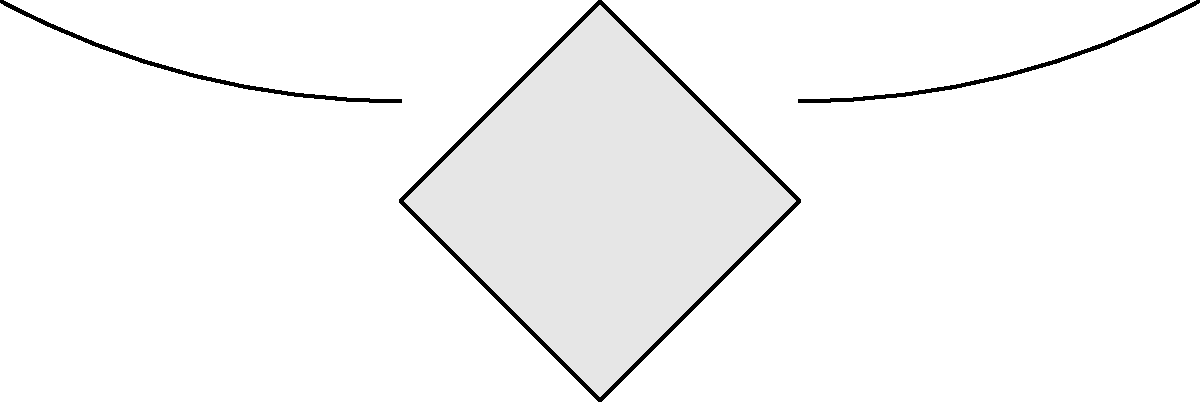As a menopause specialist, you're creating an educational diagram about the female reproductive system. You need to translate the entire diagram 2 units to the right and 1 unit up. What would be the coordinates of the center of the right ovary after this translation, given that its original center is at (4.5, 0.5)? To solve this problem, we need to follow these steps:

1. Identify the original coordinates of the right ovary's center:
   $(x, y) = (4.5, 0.5)$

2. Determine the translation vector:
   2 units right: $\Delta x = 2$
   1 unit up: $\Delta y = 1$
   Translation vector: $(2, 1)$

3. Apply the translation to the original coordinates:
   New $x$ coordinate: $x_{new} = x + \Delta x = 4.5 + 2 = 6.5$
   New $y$ coordinate: $y_{new} = y + \Delta y = 0.5 + 1 = 1.5$

4. Express the new coordinates as an ordered pair:
   $(x_{new}, y_{new}) = (6.5, 1.5)$

This translation effectively moves every point of the diagram, including the center of the right ovary, 2 units to the right and 1 unit up.
Answer: $(6.5, 1.5)$ 